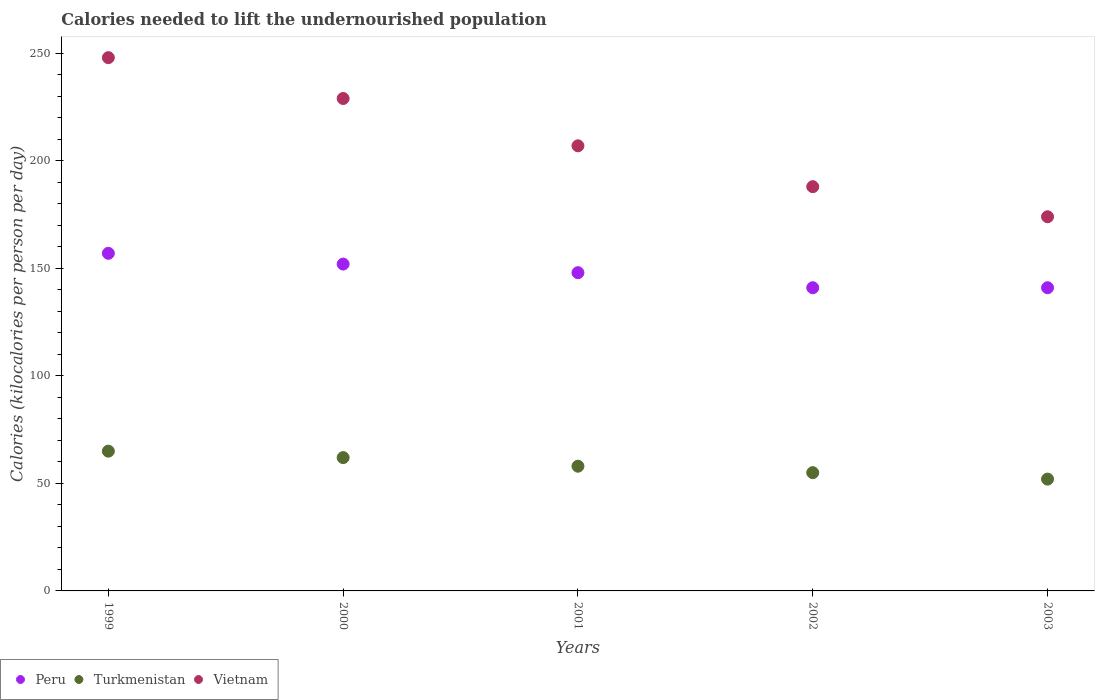Is the number of dotlines equal to the number of legend labels?
Provide a short and direct response. Yes. What is the total calories needed to lift the undernourished population in Turkmenistan in 1999?
Provide a succinct answer. 65. Across all years, what is the maximum total calories needed to lift the undernourished population in Turkmenistan?
Offer a very short reply. 65. Across all years, what is the minimum total calories needed to lift the undernourished population in Vietnam?
Your answer should be very brief. 174. In which year was the total calories needed to lift the undernourished population in Peru minimum?
Your answer should be compact. 2002. What is the total total calories needed to lift the undernourished population in Turkmenistan in the graph?
Give a very brief answer. 292. What is the difference between the total calories needed to lift the undernourished population in Turkmenistan in 2002 and that in 2003?
Give a very brief answer. 3. What is the difference between the total calories needed to lift the undernourished population in Vietnam in 2003 and the total calories needed to lift the undernourished population in Turkmenistan in 1999?
Offer a terse response. 109. What is the average total calories needed to lift the undernourished population in Turkmenistan per year?
Give a very brief answer. 58.4. In the year 2003, what is the difference between the total calories needed to lift the undernourished population in Turkmenistan and total calories needed to lift the undernourished population in Vietnam?
Your response must be concise. -122. What is the ratio of the total calories needed to lift the undernourished population in Turkmenistan in 2001 to that in 2003?
Provide a short and direct response. 1.12. Is the difference between the total calories needed to lift the undernourished population in Turkmenistan in 2000 and 2002 greater than the difference between the total calories needed to lift the undernourished population in Vietnam in 2000 and 2002?
Offer a very short reply. No. What is the difference between the highest and the lowest total calories needed to lift the undernourished population in Peru?
Make the answer very short. 16. Is the sum of the total calories needed to lift the undernourished population in Vietnam in 2001 and 2003 greater than the maximum total calories needed to lift the undernourished population in Peru across all years?
Make the answer very short. Yes. Is it the case that in every year, the sum of the total calories needed to lift the undernourished population in Vietnam and total calories needed to lift the undernourished population in Peru  is greater than the total calories needed to lift the undernourished population in Turkmenistan?
Your response must be concise. Yes. Is the total calories needed to lift the undernourished population in Peru strictly greater than the total calories needed to lift the undernourished population in Turkmenistan over the years?
Keep it short and to the point. Yes. Is the total calories needed to lift the undernourished population in Peru strictly less than the total calories needed to lift the undernourished population in Vietnam over the years?
Your answer should be very brief. Yes. How many dotlines are there?
Provide a short and direct response. 3. How many years are there in the graph?
Make the answer very short. 5. What is the difference between two consecutive major ticks on the Y-axis?
Make the answer very short. 50. Does the graph contain any zero values?
Give a very brief answer. No. Does the graph contain grids?
Your answer should be compact. No. What is the title of the graph?
Your answer should be very brief. Calories needed to lift the undernourished population. What is the label or title of the X-axis?
Ensure brevity in your answer.  Years. What is the label or title of the Y-axis?
Provide a succinct answer. Calories (kilocalories per person per day). What is the Calories (kilocalories per person per day) of Peru in 1999?
Provide a succinct answer. 157. What is the Calories (kilocalories per person per day) in Turkmenistan in 1999?
Provide a succinct answer. 65. What is the Calories (kilocalories per person per day) in Vietnam in 1999?
Provide a succinct answer. 248. What is the Calories (kilocalories per person per day) of Peru in 2000?
Provide a short and direct response. 152. What is the Calories (kilocalories per person per day) of Turkmenistan in 2000?
Ensure brevity in your answer.  62. What is the Calories (kilocalories per person per day) in Vietnam in 2000?
Your answer should be compact. 229. What is the Calories (kilocalories per person per day) of Peru in 2001?
Keep it short and to the point. 148. What is the Calories (kilocalories per person per day) in Vietnam in 2001?
Your response must be concise. 207. What is the Calories (kilocalories per person per day) in Peru in 2002?
Ensure brevity in your answer.  141. What is the Calories (kilocalories per person per day) in Vietnam in 2002?
Your answer should be very brief. 188. What is the Calories (kilocalories per person per day) in Peru in 2003?
Provide a short and direct response. 141. What is the Calories (kilocalories per person per day) in Vietnam in 2003?
Ensure brevity in your answer.  174. Across all years, what is the maximum Calories (kilocalories per person per day) in Peru?
Offer a terse response. 157. Across all years, what is the maximum Calories (kilocalories per person per day) in Turkmenistan?
Provide a short and direct response. 65. Across all years, what is the maximum Calories (kilocalories per person per day) of Vietnam?
Provide a short and direct response. 248. Across all years, what is the minimum Calories (kilocalories per person per day) of Peru?
Your response must be concise. 141. Across all years, what is the minimum Calories (kilocalories per person per day) in Turkmenistan?
Ensure brevity in your answer.  52. Across all years, what is the minimum Calories (kilocalories per person per day) in Vietnam?
Offer a terse response. 174. What is the total Calories (kilocalories per person per day) in Peru in the graph?
Your response must be concise. 739. What is the total Calories (kilocalories per person per day) of Turkmenistan in the graph?
Provide a short and direct response. 292. What is the total Calories (kilocalories per person per day) in Vietnam in the graph?
Ensure brevity in your answer.  1046. What is the difference between the Calories (kilocalories per person per day) of Peru in 1999 and that in 2000?
Provide a succinct answer. 5. What is the difference between the Calories (kilocalories per person per day) of Turkmenistan in 1999 and that in 2000?
Ensure brevity in your answer.  3. What is the difference between the Calories (kilocalories per person per day) of Peru in 1999 and that in 2001?
Your response must be concise. 9. What is the difference between the Calories (kilocalories per person per day) in Turkmenistan in 1999 and that in 2001?
Your response must be concise. 7. What is the difference between the Calories (kilocalories per person per day) of Vietnam in 1999 and that in 2001?
Keep it short and to the point. 41. What is the difference between the Calories (kilocalories per person per day) in Peru in 1999 and that in 2002?
Provide a short and direct response. 16. What is the difference between the Calories (kilocalories per person per day) of Turkmenistan in 1999 and that in 2002?
Offer a very short reply. 10. What is the difference between the Calories (kilocalories per person per day) of Peru in 1999 and that in 2003?
Offer a very short reply. 16. What is the difference between the Calories (kilocalories per person per day) in Turkmenistan in 1999 and that in 2003?
Your answer should be very brief. 13. What is the difference between the Calories (kilocalories per person per day) in Vietnam in 1999 and that in 2003?
Give a very brief answer. 74. What is the difference between the Calories (kilocalories per person per day) in Peru in 2000 and that in 2001?
Offer a terse response. 4. What is the difference between the Calories (kilocalories per person per day) in Turkmenistan in 2000 and that in 2001?
Offer a very short reply. 4. What is the difference between the Calories (kilocalories per person per day) in Vietnam in 2000 and that in 2001?
Make the answer very short. 22. What is the difference between the Calories (kilocalories per person per day) in Turkmenistan in 2000 and that in 2002?
Provide a short and direct response. 7. What is the difference between the Calories (kilocalories per person per day) in Vietnam in 2000 and that in 2002?
Your response must be concise. 41. What is the difference between the Calories (kilocalories per person per day) of Peru in 2000 and that in 2003?
Your answer should be compact. 11. What is the difference between the Calories (kilocalories per person per day) in Turkmenistan in 2000 and that in 2003?
Give a very brief answer. 10. What is the difference between the Calories (kilocalories per person per day) of Vietnam in 2000 and that in 2003?
Make the answer very short. 55. What is the difference between the Calories (kilocalories per person per day) in Vietnam in 2001 and that in 2003?
Your answer should be compact. 33. What is the difference between the Calories (kilocalories per person per day) of Peru in 1999 and the Calories (kilocalories per person per day) of Turkmenistan in 2000?
Offer a very short reply. 95. What is the difference between the Calories (kilocalories per person per day) of Peru in 1999 and the Calories (kilocalories per person per day) of Vietnam in 2000?
Offer a terse response. -72. What is the difference between the Calories (kilocalories per person per day) in Turkmenistan in 1999 and the Calories (kilocalories per person per day) in Vietnam in 2000?
Make the answer very short. -164. What is the difference between the Calories (kilocalories per person per day) of Peru in 1999 and the Calories (kilocalories per person per day) of Vietnam in 2001?
Give a very brief answer. -50. What is the difference between the Calories (kilocalories per person per day) in Turkmenistan in 1999 and the Calories (kilocalories per person per day) in Vietnam in 2001?
Offer a very short reply. -142. What is the difference between the Calories (kilocalories per person per day) of Peru in 1999 and the Calories (kilocalories per person per day) of Turkmenistan in 2002?
Keep it short and to the point. 102. What is the difference between the Calories (kilocalories per person per day) in Peru in 1999 and the Calories (kilocalories per person per day) in Vietnam in 2002?
Make the answer very short. -31. What is the difference between the Calories (kilocalories per person per day) of Turkmenistan in 1999 and the Calories (kilocalories per person per day) of Vietnam in 2002?
Your answer should be very brief. -123. What is the difference between the Calories (kilocalories per person per day) in Peru in 1999 and the Calories (kilocalories per person per day) in Turkmenistan in 2003?
Your answer should be compact. 105. What is the difference between the Calories (kilocalories per person per day) in Peru in 1999 and the Calories (kilocalories per person per day) in Vietnam in 2003?
Provide a succinct answer. -17. What is the difference between the Calories (kilocalories per person per day) in Turkmenistan in 1999 and the Calories (kilocalories per person per day) in Vietnam in 2003?
Your response must be concise. -109. What is the difference between the Calories (kilocalories per person per day) of Peru in 2000 and the Calories (kilocalories per person per day) of Turkmenistan in 2001?
Ensure brevity in your answer.  94. What is the difference between the Calories (kilocalories per person per day) in Peru in 2000 and the Calories (kilocalories per person per day) in Vietnam in 2001?
Provide a succinct answer. -55. What is the difference between the Calories (kilocalories per person per day) of Turkmenistan in 2000 and the Calories (kilocalories per person per day) of Vietnam in 2001?
Your answer should be compact. -145. What is the difference between the Calories (kilocalories per person per day) in Peru in 2000 and the Calories (kilocalories per person per day) in Turkmenistan in 2002?
Your answer should be compact. 97. What is the difference between the Calories (kilocalories per person per day) in Peru in 2000 and the Calories (kilocalories per person per day) in Vietnam in 2002?
Offer a terse response. -36. What is the difference between the Calories (kilocalories per person per day) in Turkmenistan in 2000 and the Calories (kilocalories per person per day) in Vietnam in 2002?
Your answer should be compact. -126. What is the difference between the Calories (kilocalories per person per day) of Peru in 2000 and the Calories (kilocalories per person per day) of Turkmenistan in 2003?
Keep it short and to the point. 100. What is the difference between the Calories (kilocalories per person per day) of Turkmenistan in 2000 and the Calories (kilocalories per person per day) of Vietnam in 2003?
Offer a very short reply. -112. What is the difference between the Calories (kilocalories per person per day) in Peru in 2001 and the Calories (kilocalories per person per day) in Turkmenistan in 2002?
Offer a very short reply. 93. What is the difference between the Calories (kilocalories per person per day) in Peru in 2001 and the Calories (kilocalories per person per day) in Vietnam in 2002?
Make the answer very short. -40. What is the difference between the Calories (kilocalories per person per day) of Turkmenistan in 2001 and the Calories (kilocalories per person per day) of Vietnam in 2002?
Your answer should be very brief. -130. What is the difference between the Calories (kilocalories per person per day) in Peru in 2001 and the Calories (kilocalories per person per day) in Turkmenistan in 2003?
Your answer should be compact. 96. What is the difference between the Calories (kilocalories per person per day) in Peru in 2001 and the Calories (kilocalories per person per day) in Vietnam in 2003?
Keep it short and to the point. -26. What is the difference between the Calories (kilocalories per person per day) of Turkmenistan in 2001 and the Calories (kilocalories per person per day) of Vietnam in 2003?
Provide a succinct answer. -116. What is the difference between the Calories (kilocalories per person per day) in Peru in 2002 and the Calories (kilocalories per person per day) in Turkmenistan in 2003?
Provide a succinct answer. 89. What is the difference between the Calories (kilocalories per person per day) in Peru in 2002 and the Calories (kilocalories per person per day) in Vietnam in 2003?
Make the answer very short. -33. What is the difference between the Calories (kilocalories per person per day) of Turkmenistan in 2002 and the Calories (kilocalories per person per day) of Vietnam in 2003?
Ensure brevity in your answer.  -119. What is the average Calories (kilocalories per person per day) in Peru per year?
Your response must be concise. 147.8. What is the average Calories (kilocalories per person per day) of Turkmenistan per year?
Keep it short and to the point. 58.4. What is the average Calories (kilocalories per person per day) in Vietnam per year?
Make the answer very short. 209.2. In the year 1999, what is the difference between the Calories (kilocalories per person per day) of Peru and Calories (kilocalories per person per day) of Turkmenistan?
Your answer should be compact. 92. In the year 1999, what is the difference between the Calories (kilocalories per person per day) in Peru and Calories (kilocalories per person per day) in Vietnam?
Give a very brief answer. -91. In the year 1999, what is the difference between the Calories (kilocalories per person per day) of Turkmenistan and Calories (kilocalories per person per day) of Vietnam?
Your answer should be very brief. -183. In the year 2000, what is the difference between the Calories (kilocalories per person per day) in Peru and Calories (kilocalories per person per day) in Vietnam?
Offer a very short reply. -77. In the year 2000, what is the difference between the Calories (kilocalories per person per day) in Turkmenistan and Calories (kilocalories per person per day) in Vietnam?
Your answer should be very brief. -167. In the year 2001, what is the difference between the Calories (kilocalories per person per day) of Peru and Calories (kilocalories per person per day) of Vietnam?
Offer a very short reply. -59. In the year 2001, what is the difference between the Calories (kilocalories per person per day) in Turkmenistan and Calories (kilocalories per person per day) in Vietnam?
Your answer should be compact. -149. In the year 2002, what is the difference between the Calories (kilocalories per person per day) in Peru and Calories (kilocalories per person per day) in Vietnam?
Offer a very short reply. -47. In the year 2002, what is the difference between the Calories (kilocalories per person per day) in Turkmenistan and Calories (kilocalories per person per day) in Vietnam?
Keep it short and to the point. -133. In the year 2003, what is the difference between the Calories (kilocalories per person per day) of Peru and Calories (kilocalories per person per day) of Turkmenistan?
Ensure brevity in your answer.  89. In the year 2003, what is the difference between the Calories (kilocalories per person per day) in Peru and Calories (kilocalories per person per day) in Vietnam?
Provide a succinct answer. -33. In the year 2003, what is the difference between the Calories (kilocalories per person per day) of Turkmenistan and Calories (kilocalories per person per day) of Vietnam?
Offer a terse response. -122. What is the ratio of the Calories (kilocalories per person per day) in Peru in 1999 to that in 2000?
Offer a very short reply. 1.03. What is the ratio of the Calories (kilocalories per person per day) of Turkmenistan in 1999 to that in 2000?
Your answer should be compact. 1.05. What is the ratio of the Calories (kilocalories per person per day) of Vietnam in 1999 to that in 2000?
Your answer should be compact. 1.08. What is the ratio of the Calories (kilocalories per person per day) in Peru in 1999 to that in 2001?
Your response must be concise. 1.06. What is the ratio of the Calories (kilocalories per person per day) of Turkmenistan in 1999 to that in 2001?
Offer a very short reply. 1.12. What is the ratio of the Calories (kilocalories per person per day) of Vietnam in 1999 to that in 2001?
Offer a very short reply. 1.2. What is the ratio of the Calories (kilocalories per person per day) of Peru in 1999 to that in 2002?
Make the answer very short. 1.11. What is the ratio of the Calories (kilocalories per person per day) of Turkmenistan in 1999 to that in 2002?
Your answer should be very brief. 1.18. What is the ratio of the Calories (kilocalories per person per day) of Vietnam in 1999 to that in 2002?
Ensure brevity in your answer.  1.32. What is the ratio of the Calories (kilocalories per person per day) in Peru in 1999 to that in 2003?
Ensure brevity in your answer.  1.11. What is the ratio of the Calories (kilocalories per person per day) in Vietnam in 1999 to that in 2003?
Your answer should be very brief. 1.43. What is the ratio of the Calories (kilocalories per person per day) in Peru in 2000 to that in 2001?
Provide a succinct answer. 1.03. What is the ratio of the Calories (kilocalories per person per day) in Turkmenistan in 2000 to that in 2001?
Make the answer very short. 1.07. What is the ratio of the Calories (kilocalories per person per day) in Vietnam in 2000 to that in 2001?
Give a very brief answer. 1.11. What is the ratio of the Calories (kilocalories per person per day) of Peru in 2000 to that in 2002?
Keep it short and to the point. 1.08. What is the ratio of the Calories (kilocalories per person per day) of Turkmenistan in 2000 to that in 2002?
Your answer should be compact. 1.13. What is the ratio of the Calories (kilocalories per person per day) of Vietnam in 2000 to that in 2002?
Offer a terse response. 1.22. What is the ratio of the Calories (kilocalories per person per day) of Peru in 2000 to that in 2003?
Provide a short and direct response. 1.08. What is the ratio of the Calories (kilocalories per person per day) in Turkmenistan in 2000 to that in 2003?
Provide a succinct answer. 1.19. What is the ratio of the Calories (kilocalories per person per day) of Vietnam in 2000 to that in 2003?
Keep it short and to the point. 1.32. What is the ratio of the Calories (kilocalories per person per day) in Peru in 2001 to that in 2002?
Keep it short and to the point. 1.05. What is the ratio of the Calories (kilocalories per person per day) of Turkmenistan in 2001 to that in 2002?
Give a very brief answer. 1.05. What is the ratio of the Calories (kilocalories per person per day) of Vietnam in 2001 to that in 2002?
Keep it short and to the point. 1.1. What is the ratio of the Calories (kilocalories per person per day) of Peru in 2001 to that in 2003?
Provide a succinct answer. 1.05. What is the ratio of the Calories (kilocalories per person per day) of Turkmenistan in 2001 to that in 2003?
Provide a succinct answer. 1.12. What is the ratio of the Calories (kilocalories per person per day) in Vietnam in 2001 to that in 2003?
Your response must be concise. 1.19. What is the ratio of the Calories (kilocalories per person per day) of Turkmenistan in 2002 to that in 2003?
Offer a very short reply. 1.06. What is the ratio of the Calories (kilocalories per person per day) of Vietnam in 2002 to that in 2003?
Your response must be concise. 1.08. What is the difference between the highest and the second highest Calories (kilocalories per person per day) in Peru?
Offer a terse response. 5. What is the difference between the highest and the second highest Calories (kilocalories per person per day) of Turkmenistan?
Provide a short and direct response. 3. What is the difference between the highest and the lowest Calories (kilocalories per person per day) in Peru?
Make the answer very short. 16. What is the difference between the highest and the lowest Calories (kilocalories per person per day) in Turkmenistan?
Your response must be concise. 13. What is the difference between the highest and the lowest Calories (kilocalories per person per day) of Vietnam?
Provide a short and direct response. 74. 